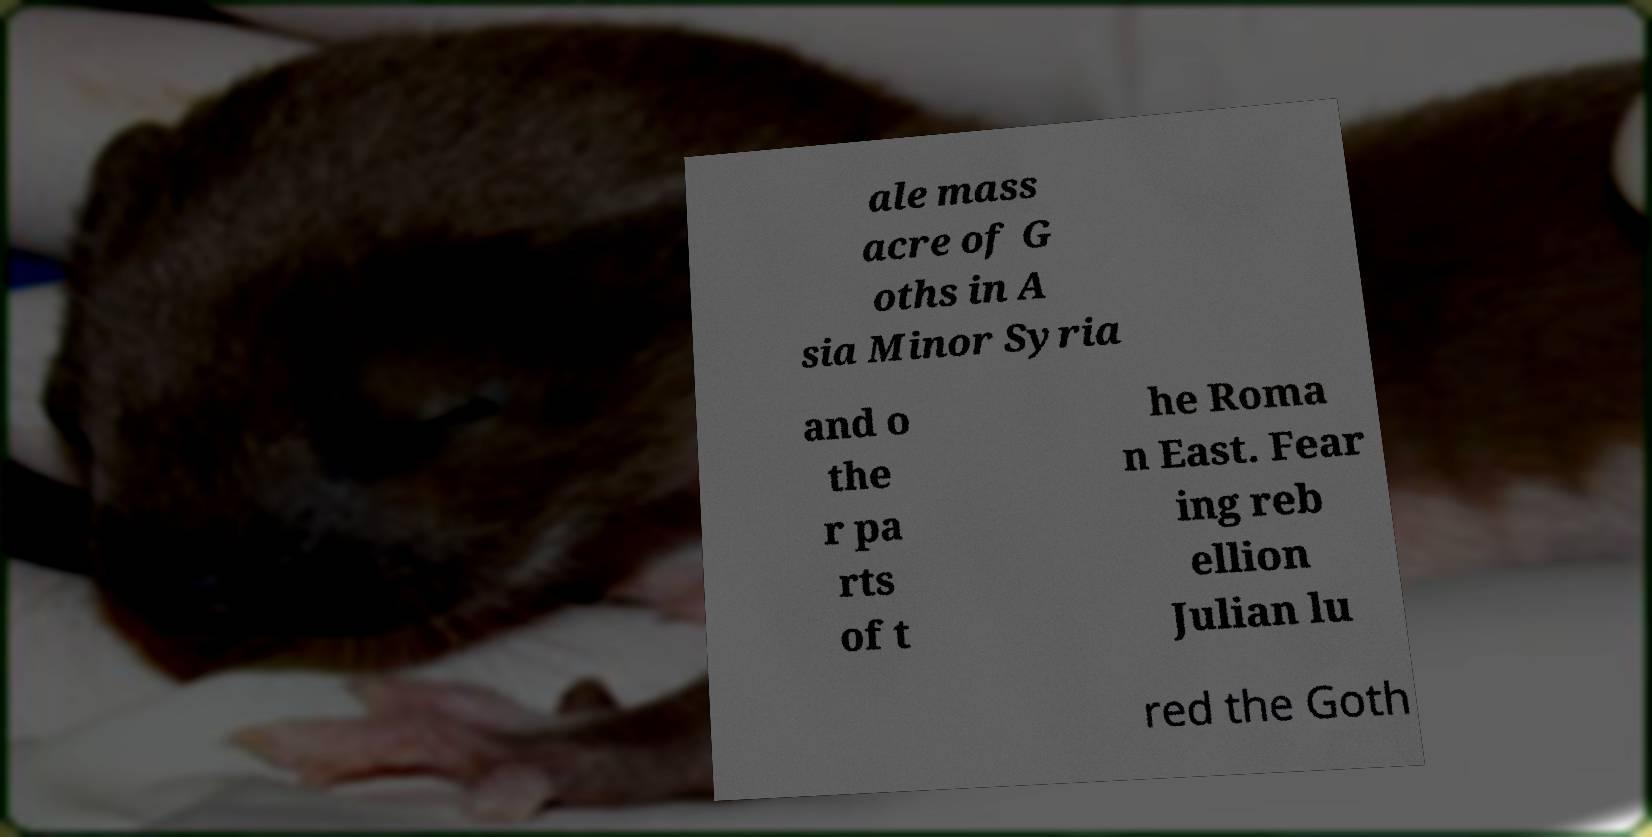For documentation purposes, I need the text within this image transcribed. Could you provide that? ale mass acre of G oths in A sia Minor Syria and o the r pa rts of t he Roma n East. Fear ing reb ellion Julian lu red the Goth 